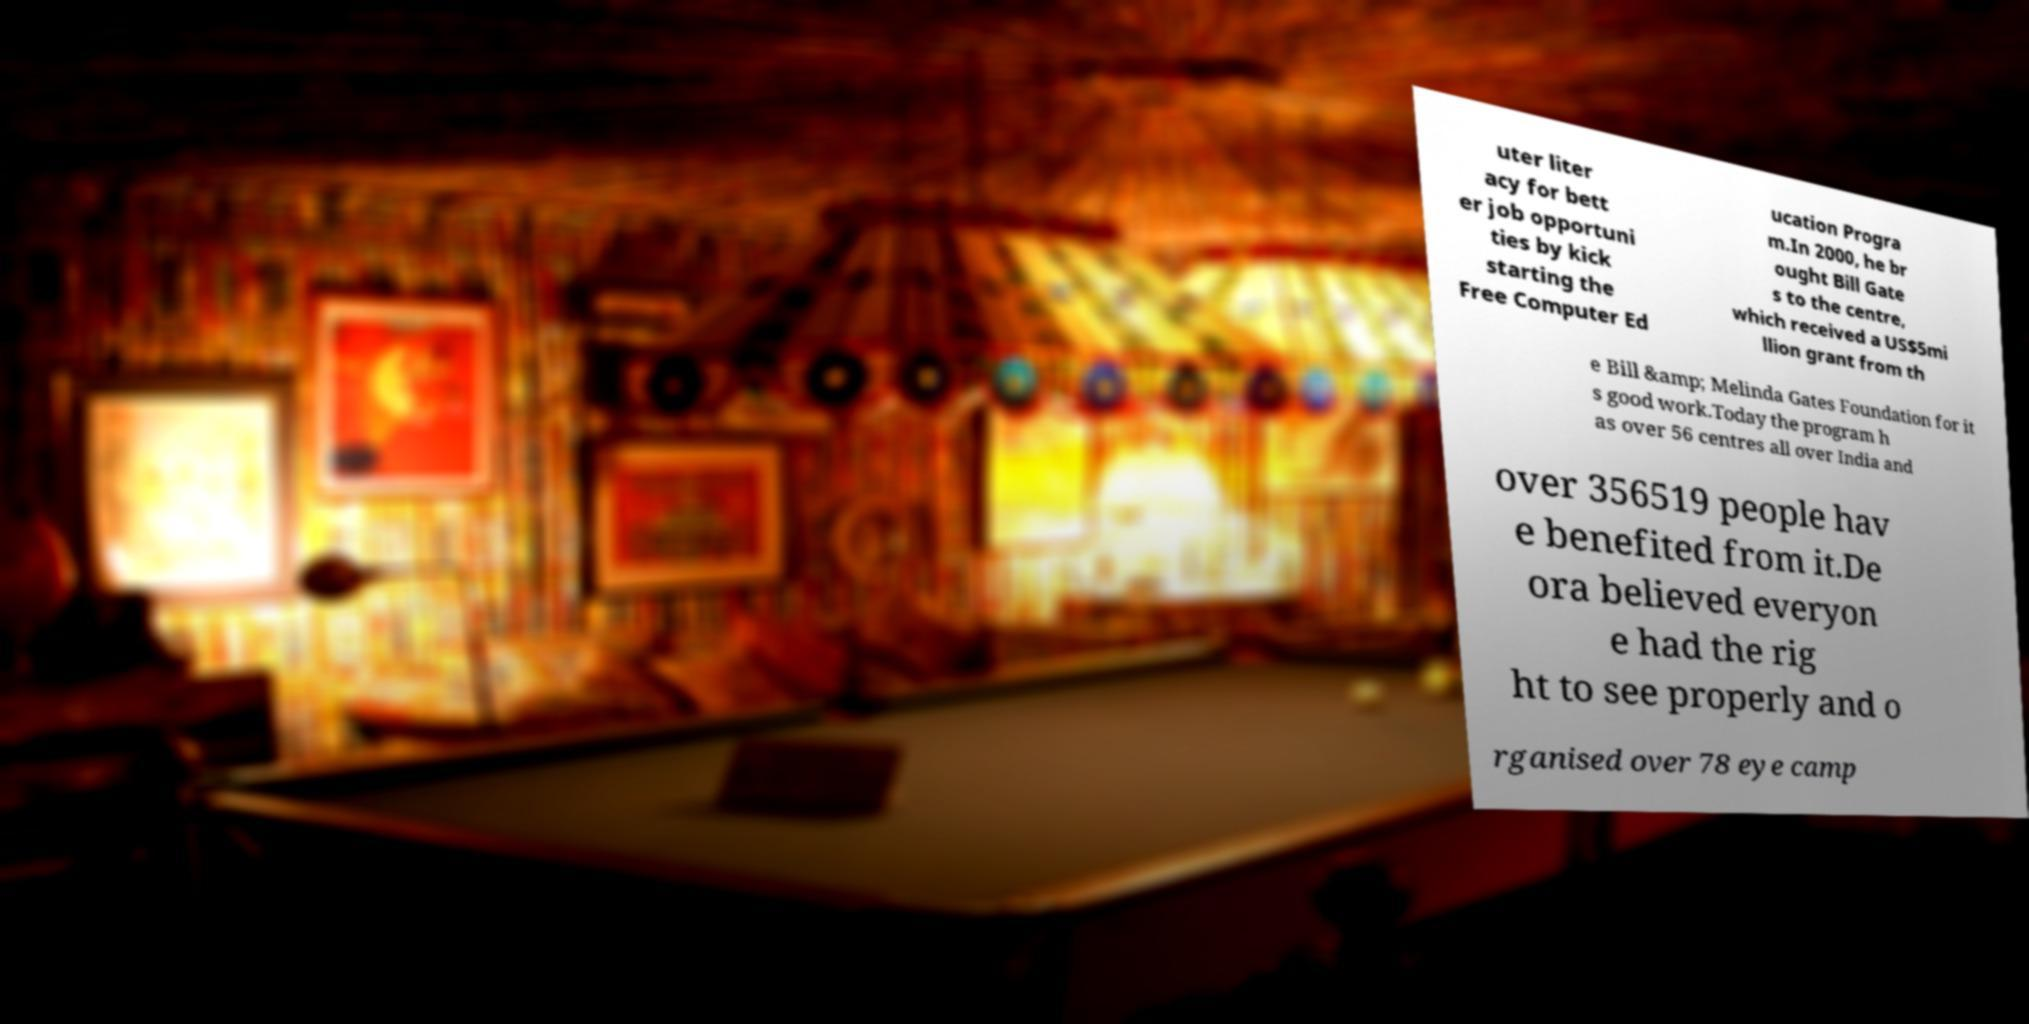There's text embedded in this image that I need extracted. Can you transcribe it verbatim? uter liter acy for bett er job opportuni ties by kick starting the Free Computer Ed ucation Progra m.In 2000, he br ought Bill Gate s to the centre, which received a US$5mi llion grant from th e Bill &amp; Melinda Gates Foundation for it s good work.Today the program h as over 56 centres all over India and over 356519 people hav e benefited from it.De ora believed everyon e had the rig ht to see properly and o rganised over 78 eye camp 